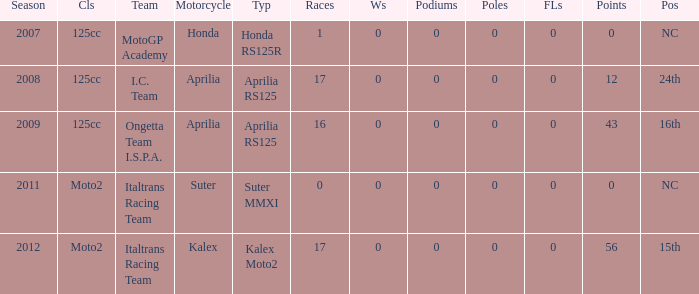What's Italtrans Racing Team's, with 0 pts, class? Moto2. Could you parse the entire table? {'header': ['Season', 'Cls', 'Team', 'Motorcycle', 'Typ', 'Races', 'Ws', 'Podiums', 'Poles', 'FLs', 'Points', 'Pos'], 'rows': [['2007', '125cc', 'MotoGP Academy', 'Honda', 'Honda RS125R', '1', '0', '0', '0', '0', '0', 'NC'], ['2008', '125cc', 'I.C. Team', 'Aprilia', 'Aprilia RS125', '17', '0', '0', '0', '0', '12', '24th'], ['2009', '125cc', 'Ongetta Team I.S.P.A.', 'Aprilia', 'Aprilia RS125', '16', '0', '0', '0', '0', '43', '16th'], ['2011', 'Moto2', 'Italtrans Racing Team', 'Suter', 'Suter MMXI', '0', '0', '0', '0', '0', '0', 'NC'], ['2012', 'Moto2', 'Italtrans Racing Team', 'Kalex', 'Kalex Moto2', '17', '0', '0', '0', '0', '56', '15th']]} 